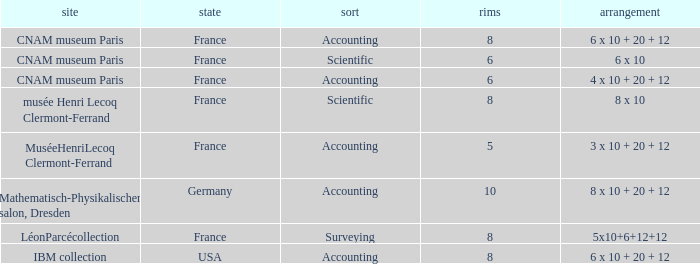What is the configuration for the country France, with accounting as the type, and wheels greater than 6? 6 x 10 + 20 + 12. 